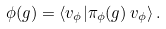<formula> <loc_0><loc_0><loc_500><loc_500>\phi ( g ) = \langle v _ { \phi } | \pi _ { \phi } ( g ) \, v _ { \phi } \rangle \, .</formula> 